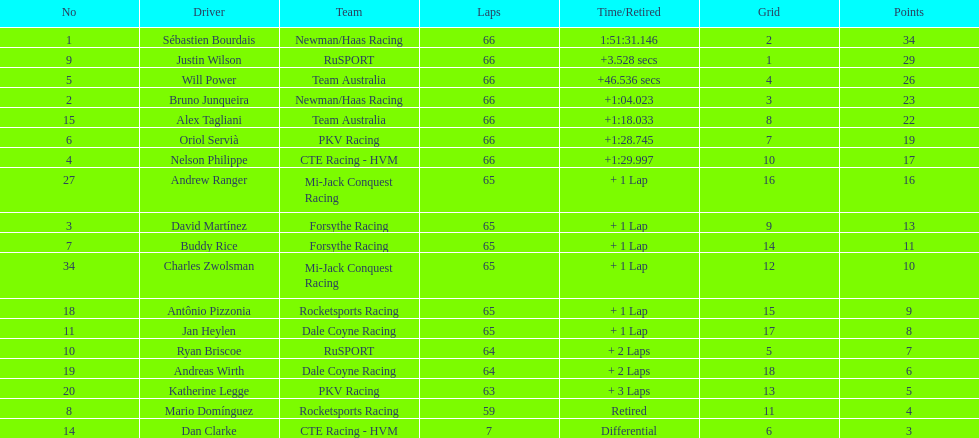Rice finished 10th. who finished next? Charles Zwolsman. 